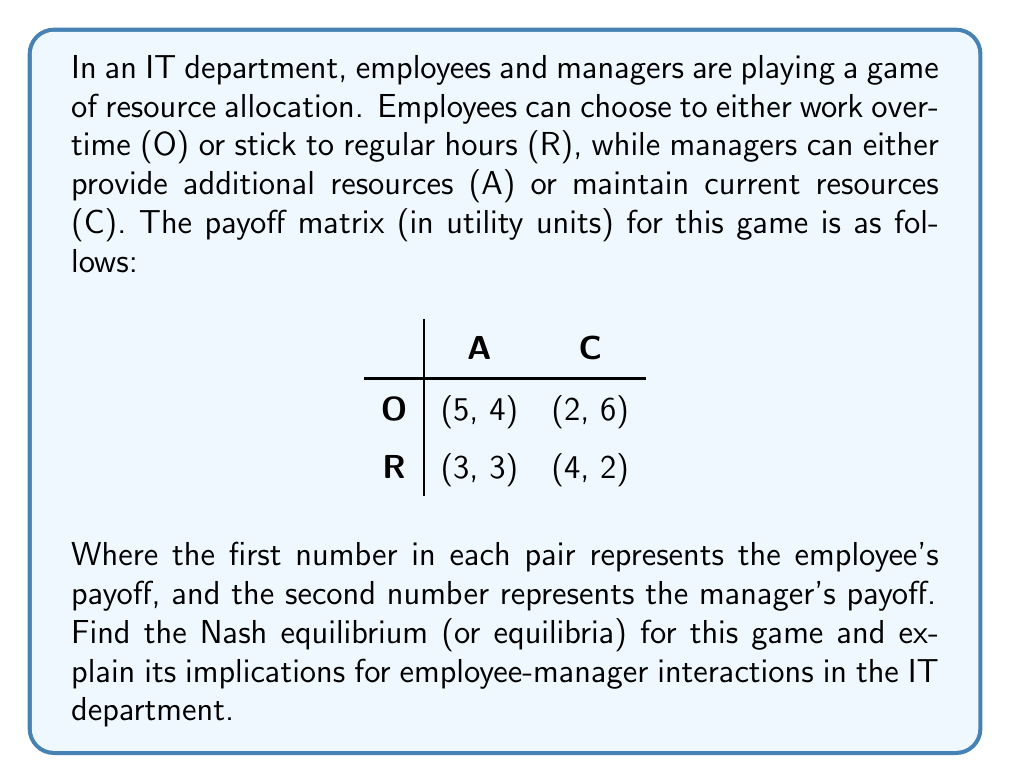Help me with this question. To find the Nash equilibrium, we need to analyze each player's best response to the other player's strategy:

1. Employee's perspective:
   - If manager chooses A: $5 > 3$, so employee prefers O
   - If manager chooses C: $4 > 2$, so employee prefers R

2. Manager's perspective:
   - If employee chooses O: $6 > 4$, so manager prefers C
   - If employee chooses R: $3 > 2$, so manager prefers A

We can see that there is no pure strategy Nash equilibrium, as there's no cell where both players are playing their best response to the other's strategy.

Therefore, we need to look for a mixed strategy Nash equilibrium. Let's define:
- $p$ = probability of employee choosing O
- $q$ = probability of manager choosing A

For the employee to be indifferent between O and R:

$$5q + 2(1-q) = 3q + 4(1-q)$$
$$5q + 2 - 2q = 3q + 4 - 4q$$
$$3q + 2 = -q + 4$$
$$4q = 2$$
$$q = \frac{1}{2}$$

For the manager to be indifferent between A and C:

$$4p + 3(1-p) = 6p + 2(1-p)$$
$$4p + 3 - 3p = 6p + 2 - 2p$$
$$p + 3 = 4p + 2$$
$$1 = 3p$$
$$p = \frac{1}{3}$$

Therefore, the mixed strategy Nash equilibrium is:
- Employee plays O with probability $\frac{1}{3}$ and R with probability $\frac{2}{3}$
- Manager plays A with probability $\frac{1}{2}$ and C with probability $\frac{1}{2}$

Implications:
1. There's no stable pure strategy, indicating a dynamic work environment.
2. Employees will work overtime about 33% of the time, balancing extra effort with regular hours.
3. Managers will provide additional resources 50% of the time, showing a balanced approach to resource allocation.
4. This equilibrium suggests a compromise between pushing for productivity and maintaining sustainable work practices in the IT department.
Answer: The Nash equilibrium is a mixed strategy where employees play Overtime (O) with probability $\frac{1}{3}$ and Regular hours (R) with probability $\frac{2}{3}$, while managers play Additional resources (A) with probability $\frac{1}{2}$ and Current resources (C) with probability $\frac{1}{2}$. 